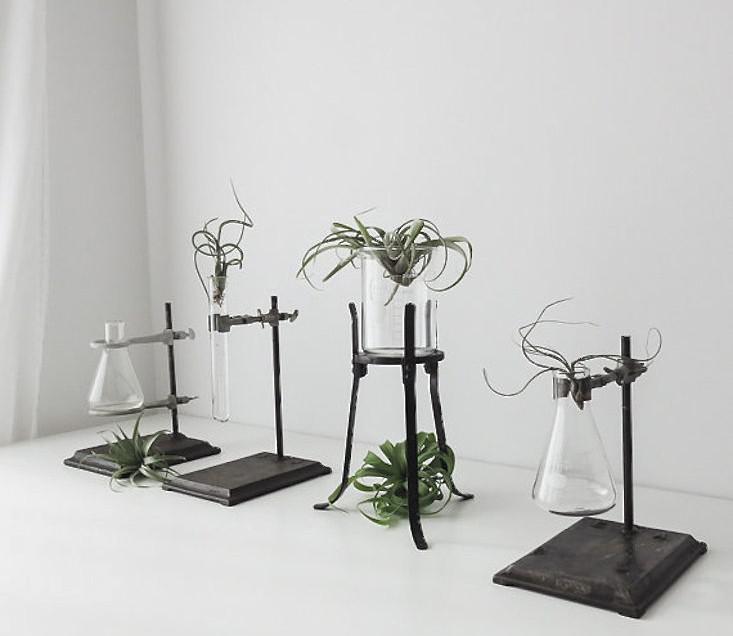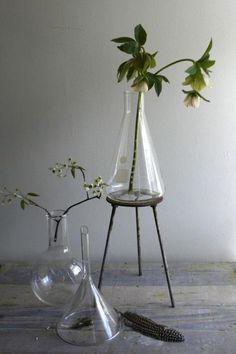The first image is the image on the left, the second image is the image on the right. Given the left and right images, does the statement "There are exactly three plants in the left image." hold true? Answer yes or no. No. 